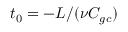<formula> <loc_0><loc_0><loc_500><loc_500>t _ { 0 } = - L / ( \nu C _ { g c } )</formula> 